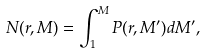Convert formula to latex. <formula><loc_0><loc_0><loc_500><loc_500>N ( r , M ) = \int _ { 1 } ^ { M } P ( r , M ^ { \prime } ) d M ^ { \prime } ,</formula> 